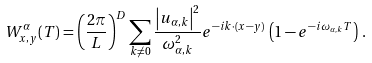<formula> <loc_0><loc_0><loc_500><loc_500>W _ { { x } , { y } } ^ { \alpha } ( T ) = \left ( \frac { 2 \pi } { L } \right ) ^ { D } \sum _ { { k } \neq 0 } \frac { \left | u _ { \alpha , k } \right | ^ { 2 } } { \omega _ { \alpha , k } ^ { 2 } } e ^ { - i { k } \cdot ( { x } - { y } ) } \, \left ( 1 - e ^ { - i \omega _ { \alpha , k } T } \right ) \, .</formula> 